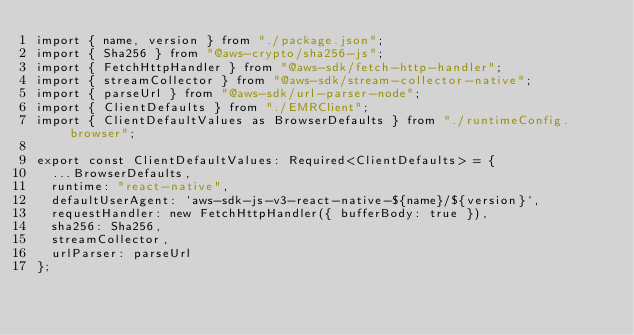<code> <loc_0><loc_0><loc_500><loc_500><_TypeScript_>import { name, version } from "./package.json";
import { Sha256 } from "@aws-crypto/sha256-js";
import { FetchHttpHandler } from "@aws-sdk/fetch-http-handler";
import { streamCollector } from "@aws-sdk/stream-collector-native";
import { parseUrl } from "@aws-sdk/url-parser-node";
import { ClientDefaults } from "./EMRClient";
import { ClientDefaultValues as BrowserDefaults } from "./runtimeConfig.browser";

export const ClientDefaultValues: Required<ClientDefaults> = {
  ...BrowserDefaults,
  runtime: "react-native",
  defaultUserAgent: `aws-sdk-js-v3-react-native-${name}/${version}`,
  requestHandler: new FetchHttpHandler({ bufferBody: true }),
  sha256: Sha256,
  streamCollector,
  urlParser: parseUrl
};
</code> 